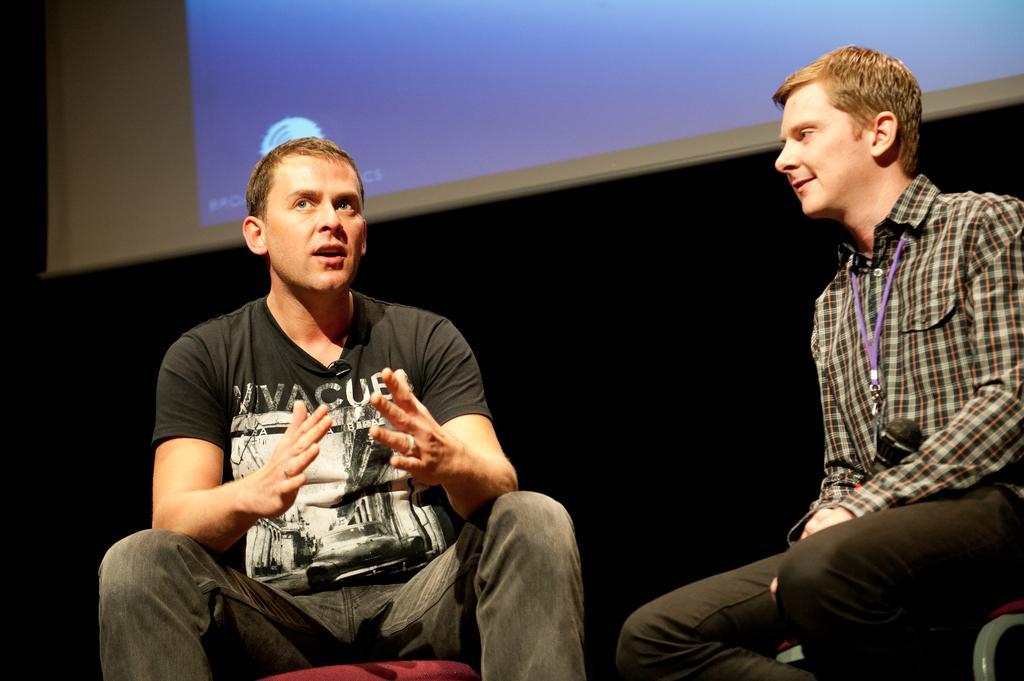In one or two sentences, can you explain what this image depicts? In this image we can see two persons sitting on chairs. Behind the persons the background is dark. At the top we can see a projected screen. 